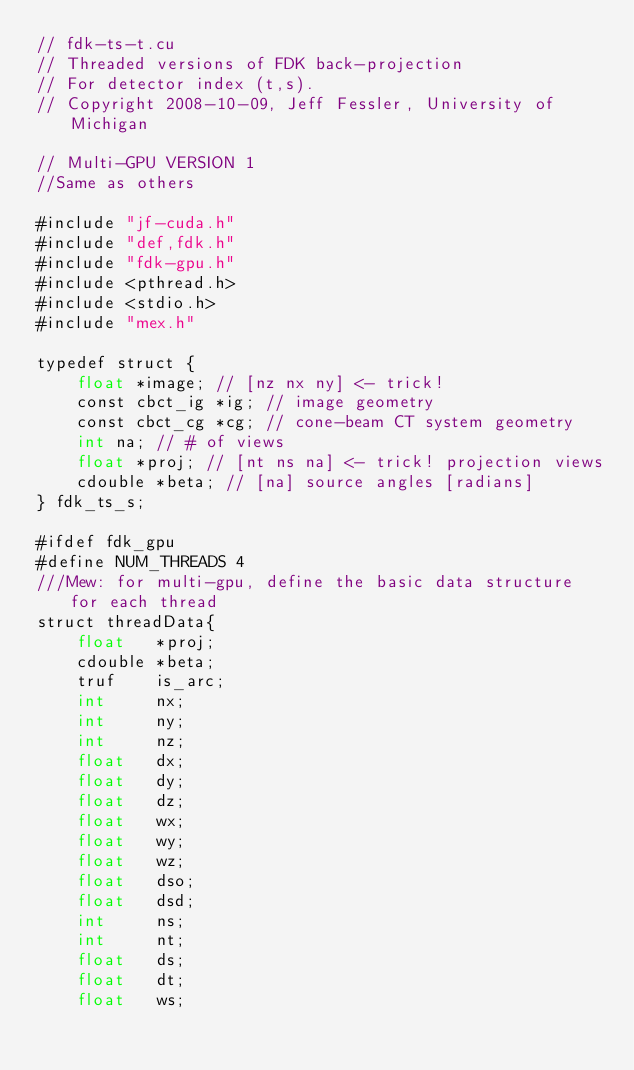<code> <loc_0><loc_0><loc_500><loc_500><_Cuda_>// fdk-ts-t.cu
// Threaded versions of FDK back-projection
// For detector index (t,s).
// Copyright 2008-10-09, Jeff Fessler, University of Michigan

// Multi-GPU VERSION 1
//Same as others 

#include "jf-cuda.h"
#include "def,fdk.h"
#include "fdk-gpu.h"
#include <pthread.h>
#include <stdio.h>
#include "mex.h"

typedef struct {
	float *image; // [nz nx ny] <- trick!
	const cbct_ig *ig; // image geometry
	const cbct_cg *cg; // cone-beam CT system geometry
	int na; // # of views
	float *proj; // [nt ns na] <- trick! projection views
	cdouble *beta; // [na] source angles [radians]
} fdk_ts_s;

#ifdef fdk_gpu
#define NUM_THREADS 4
///Mew: for multi-gpu, define the basic data structure for each thread
struct threadData{	
	float	*proj;
	cdouble	*beta;
	truf 	is_arc; 
	int 	nx; 
	int 	ny;
	int 	nz; 
	float 	dx; 
	float	dy; 
	float 	dz;
	float 	wx; 
	float 	wy;
	float	wz; 
	float 	dso; 
	float 	dsd; 
	int 	ns;
	int 	nt;
	float 	ds;
	float	dt;
	float 	ws; </code> 